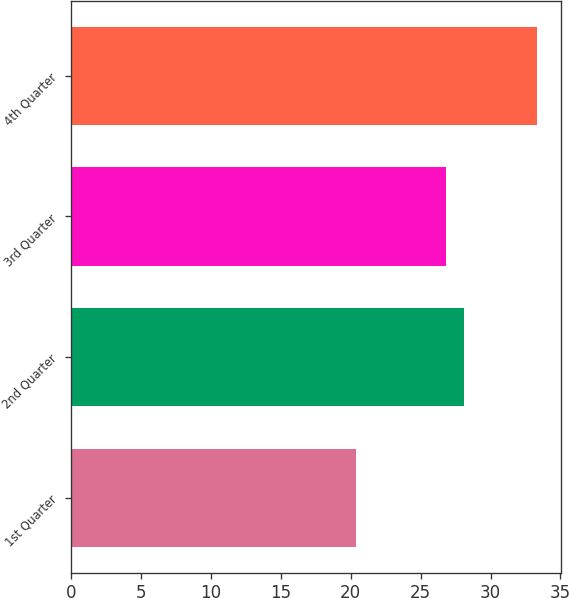Convert chart to OTSL. <chart><loc_0><loc_0><loc_500><loc_500><bar_chart><fcel>1st Quarter<fcel>2nd Quarter<fcel>3rd Quarter<fcel>4th Quarter<nl><fcel>20.4<fcel>28.12<fcel>26.83<fcel>33.34<nl></chart> 